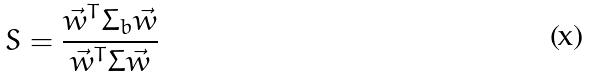Convert formula to latex. <formula><loc_0><loc_0><loc_500><loc_500>S = \frac { \vec { w } ^ { T } \Sigma _ { b } \vec { w } } { \vec { w } ^ { T } \Sigma \vec { w } }</formula> 